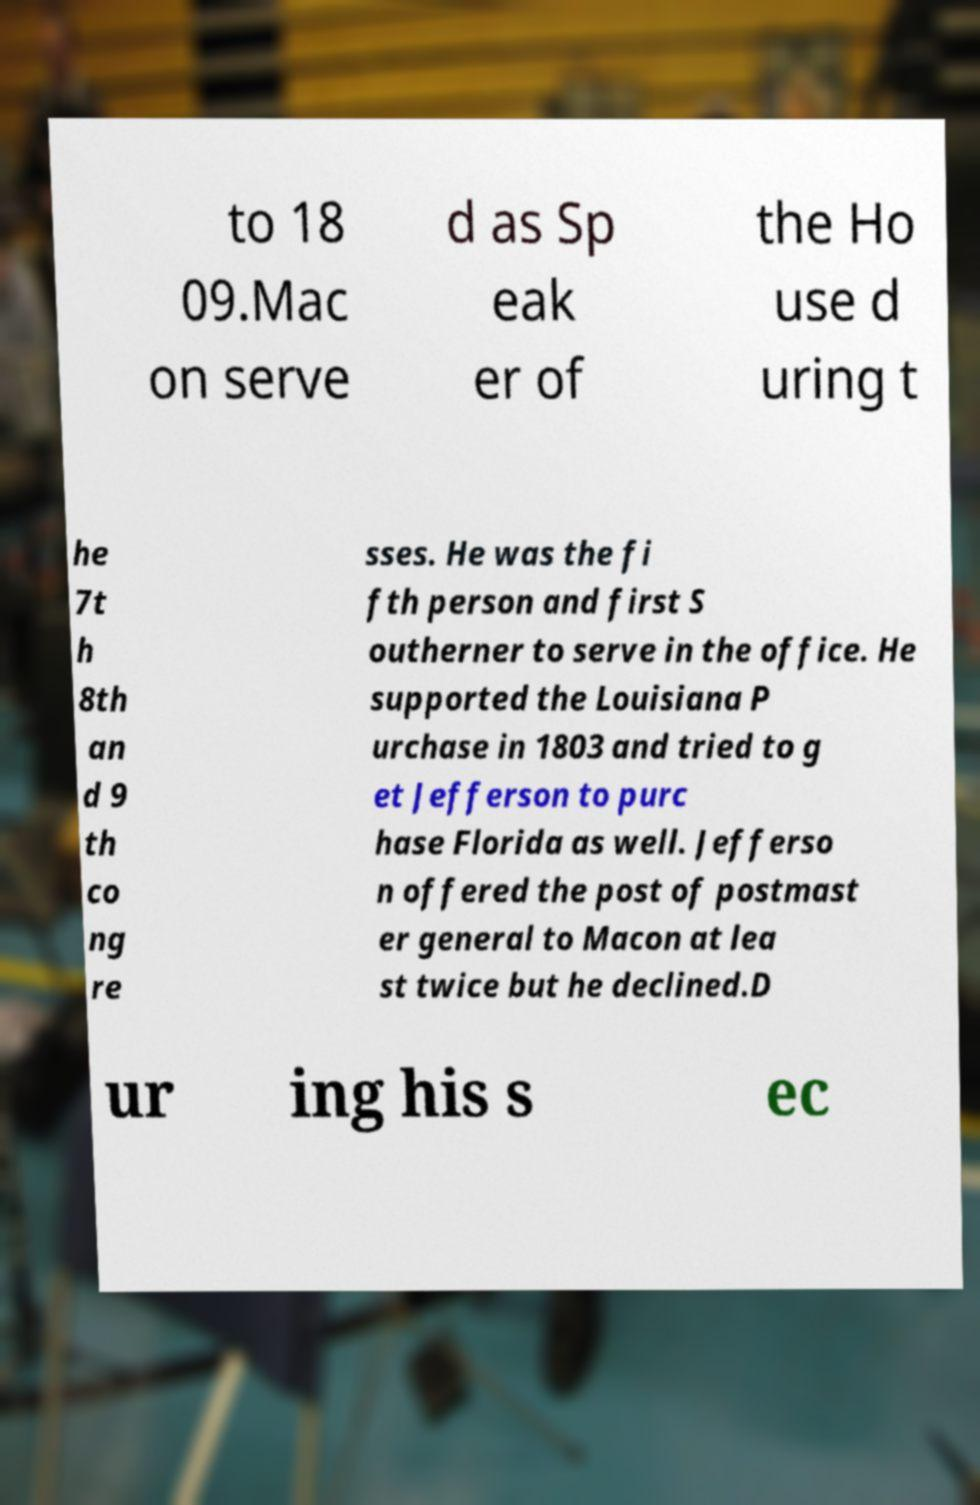Please read and relay the text visible in this image. What does it say? to 18 09.Mac on serve d as Sp eak er of the Ho use d uring t he 7t h 8th an d 9 th co ng re sses. He was the fi fth person and first S outherner to serve in the office. He supported the Louisiana P urchase in 1803 and tried to g et Jefferson to purc hase Florida as well. Jefferso n offered the post of postmast er general to Macon at lea st twice but he declined.D ur ing his s ec 